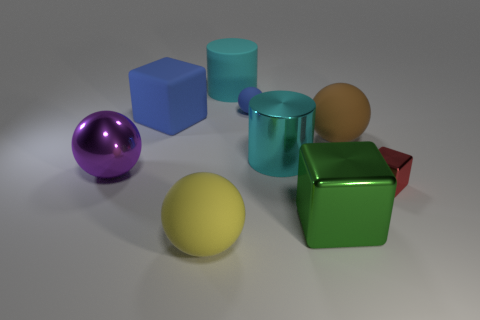Are there any other things that have the same color as the tiny block?
Ensure brevity in your answer.  No. Is the shape of the yellow object the same as the metal thing that is left of the small sphere?
Your response must be concise. Yes. How many big things are either yellow metal things or cylinders?
Your answer should be very brief. 2. Is there a brown rubber ball of the same size as the cyan rubber cylinder?
Your response must be concise. Yes. What is the color of the small thing that is on the left side of the big cyan cylinder that is in front of the cyan cylinder that is behind the large cyan metal cylinder?
Your answer should be very brief. Blue. Is the material of the yellow thing the same as the big cyan thing that is on the left side of the cyan metallic object?
Your answer should be compact. Yes. What size is the metal thing that is the same shape as the big cyan rubber object?
Provide a succinct answer. Large. Is the number of blue cubes that are in front of the big shiny cube the same as the number of large spheres to the left of the big cyan metal cylinder?
Ensure brevity in your answer.  No. How many other things are the same material as the small sphere?
Make the answer very short. 4. Is the number of shiny blocks in front of the small blue ball the same as the number of tiny blocks?
Offer a terse response. No. 